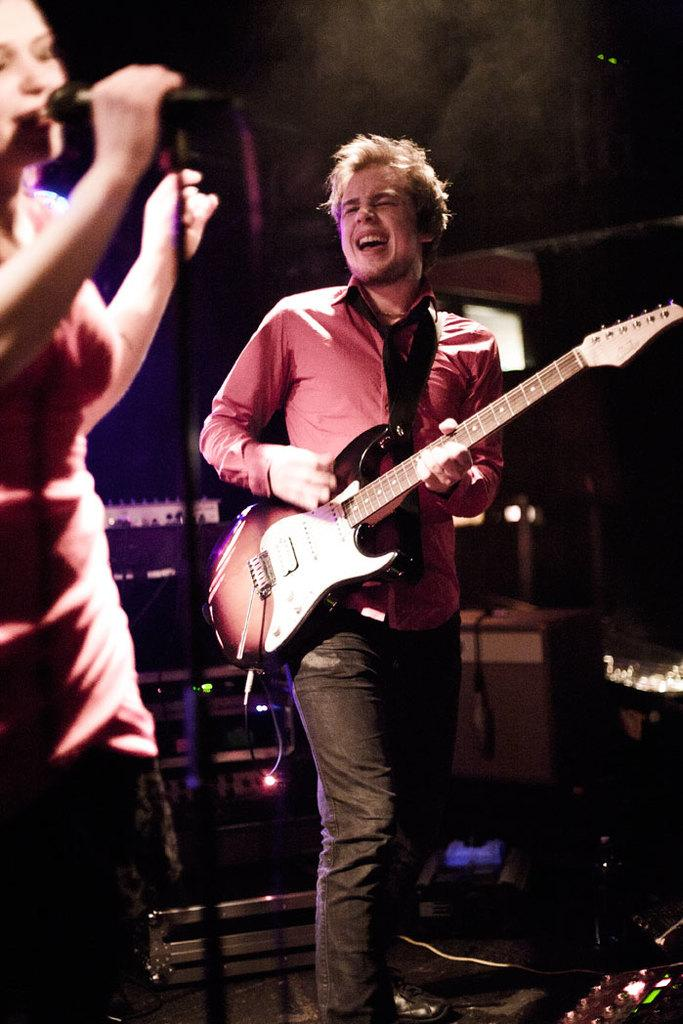What is the man in the image doing? The man is standing, playing a guitar, and singing. What is the woman in the image doing? The woman is standing, holding a microphone, and singing. How many people are present in the image? There are two people in the image, a man and a woman. What type of brick is the actor using as a prop in the image? There is no actor or brick present in the image. How many women are visible in the image? There is only one woman visible in the image. 